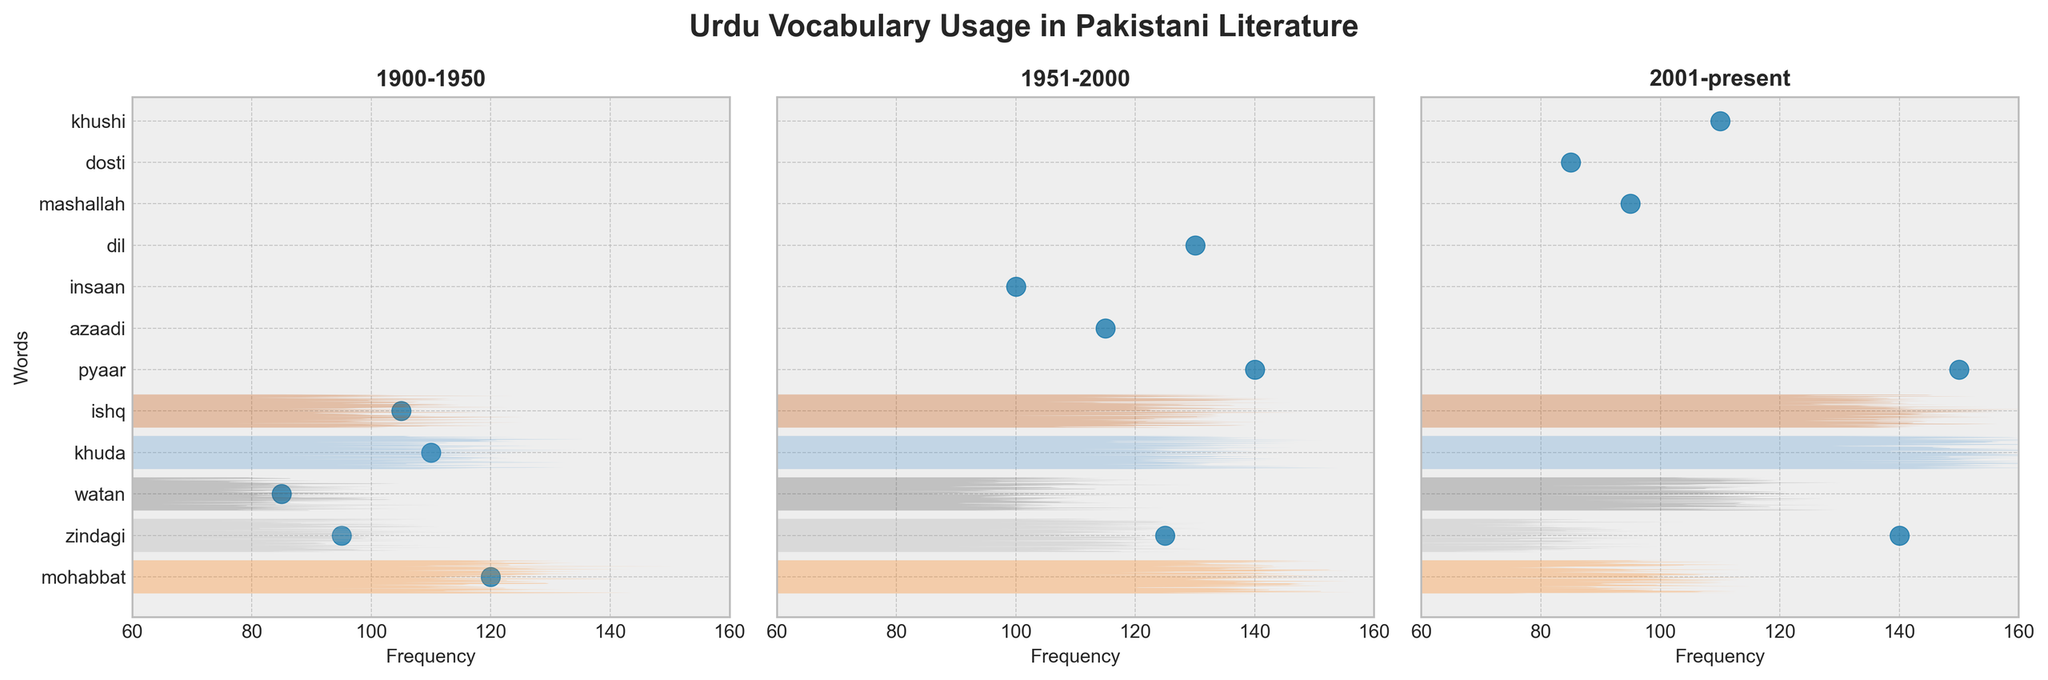Which time period shows the highest frequency for the word 'zindagi'? To answer this, we compare the frequencies of the word 'zindagi' across the three time periods in the plot. It's 95 for 1900-1950, 125 for 1951-2000, and 140 for 2001-present. The highest frequency is 140, in the 2001-present period.
Answer: 2001-present What is the title of the figure? The title is positioned at the top center of the figure. It reads, "Urdu Vocabulary Usage in Pakistani Literature".
Answer: Urdu Vocabulary Usage in Pakistani Literature What is the average frequency of the word 'pyaar' across all time periods? First, gather the frequencies of 'pyaar' from each period: 140 (1951-2000) and 150 (2001-present). Then, average these values: (140 + 150) / 2 = 145.
Answer: 145 Compare the frequencies of 'khuda' and 'dosti'. Which word has the higher frequency and by how much? 'Khuda' has a frequency of 110 (1900-1950), and 'dosti' has a frequency of 85 (2001-present). The difference in their frequencies is 110 - 85 = 25, and 'khuda' is higher.
Answer: khuda by 25 Which word appears in all three time periods? We need to identify a word present in all three scatter plots. 'Zindagi' appears in all three time periods.
Answer: zindagi Is there a word that appears only in the 2001-present period and not in the earlier periods? We examine the words in the 2001-present plot and see which are exclusive. 'Mashallah', 'dosti', and 'khushi' are unique to the 2001-present period.
Answer: mashallah, dosti, khushi What is the word with the highest frequency overall in all periods? Compare the highest frequency per word across all periods. 'Pyaar' in the 2001-present period has a frequency of 150, which is the highest overall.
Answer: pyaar How does the frequency of the word 'azadi' in 1951-2000 compare to the frequency of 'watan' in 1900-1950? The frequency of 'azadi' is 115 (1951-2000), and 'watan' is 85 (1900-1950). Thus, 'azadi' has a higher frequency, specifically 115 - 85 = 30 more.
Answer: azadi by 30 What does the y-axis represent in the plot? The y-axis labels are words in each subplot, representing the various Urdu words analyzed for their frequency across periods.
Answer: Words Identify the time period with the lowest average word frequency. Calculate the average frequency for each period: 
1900-1950: (120 + 95 + 85 + 110 + 105) / 5 = 103 
1951-2000: (140 + 115 + 100 + 130 + 125) / 5 = 122 
2001-present: (95 + 85 + 110 + 150 + 140) / 5 = 116 
The lowest average is for 1900-1950, with 103.
Answer: 1900-1950 